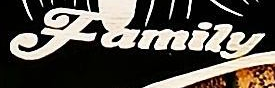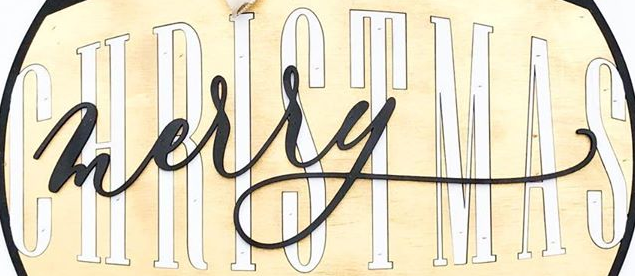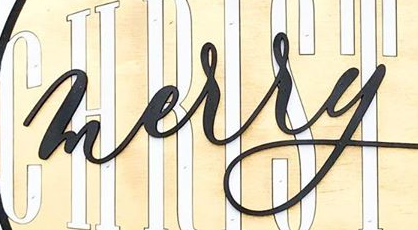Transcribe the words shown in these images in order, separated by a semicolon. Family; CHRISTMAS; merry 